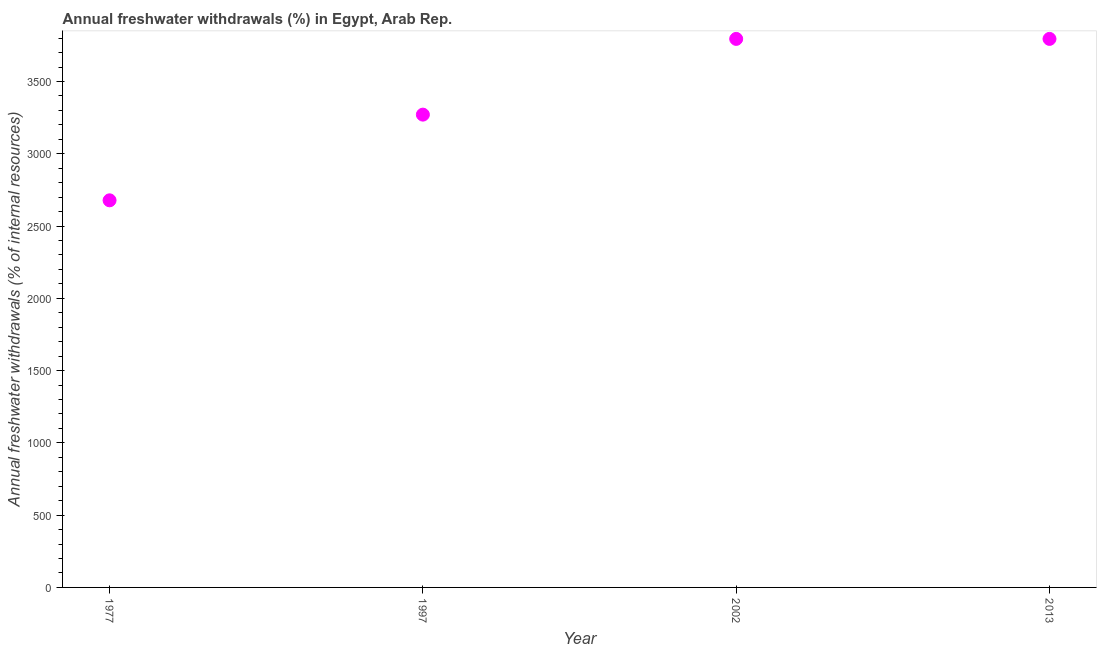What is the annual freshwater withdrawals in 1997?
Keep it short and to the point. 3270.56. Across all years, what is the maximum annual freshwater withdrawals?
Offer a very short reply. 3794.44. Across all years, what is the minimum annual freshwater withdrawals?
Offer a terse response. 2677.78. In which year was the annual freshwater withdrawals maximum?
Offer a terse response. 2002. In which year was the annual freshwater withdrawals minimum?
Make the answer very short. 1977. What is the sum of the annual freshwater withdrawals?
Your response must be concise. 1.35e+04. What is the difference between the annual freshwater withdrawals in 2002 and 2013?
Offer a terse response. 0. What is the average annual freshwater withdrawals per year?
Offer a very short reply. 3384.31. What is the median annual freshwater withdrawals?
Give a very brief answer. 3532.5. What is the ratio of the annual freshwater withdrawals in 1977 to that in 1997?
Ensure brevity in your answer.  0.82. Is the difference between the annual freshwater withdrawals in 1997 and 2002 greater than the difference between any two years?
Offer a very short reply. No. What is the difference between the highest and the second highest annual freshwater withdrawals?
Your answer should be very brief. 0. What is the difference between the highest and the lowest annual freshwater withdrawals?
Your answer should be compact. 1116.67. In how many years, is the annual freshwater withdrawals greater than the average annual freshwater withdrawals taken over all years?
Your answer should be very brief. 2. How many years are there in the graph?
Your response must be concise. 4. Does the graph contain grids?
Your answer should be compact. No. What is the title of the graph?
Make the answer very short. Annual freshwater withdrawals (%) in Egypt, Arab Rep. What is the label or title of the Y-axis?
Provide a short and direct response. Annual freshwater withdrawals (% of internal resources). What is the Annual freshwater withdrawals (% of internal resources) in 1977?
Provide a short and direct response. 2677.78. What is the Annual freshwater withdrawals (% of internal resources) in 1997?
Offer a very short reply. 3270.56. What is the Annual freshwater withdrawals (% of internal resources) in 2002?
Your answer should be very brief. 3794.44. What is the Annual freshwater withdrawals (% of internal resources) in 2013?
Give a very brief answer. 3794.44. What is the difference between the Annual freshwater withdrawals (% of internal resources) in 1977 and 1997?
Offer a very short reply. -592.78. What is the difference between the Annual freshwater withdrawals (% of internal resources) in 1977 and 2002?
Give a very brief answer. -1116.67. What is the difference between the Annual freshwater withdrawals (% of internal resources) in 1977 and 2013?
Provide a succinct answer. -1116.67. What is the difference between the Annual freshwater withdrawals (% of internal resources) in 1997 and 2002?
Provide a short and direct response. -523.89. What is the difference between the Annual freshwater withdrawals (% of internal resources) in 1997 and 2013?
Ensure brevity in your answer.  -523.89. What is the ratio of the Annual freshwater withdrawals (% of internal resources) in 1977 to that in 1997?
Ensure brevity in your answer.  0.82. What is the ratio of the Annual freshwater withdrawals (% of internal resources) in 1977 to that in 2002?
Give a very brief answer. 0.71. What is the ratio of the Annual freshwater withdrawals (% of internal resources) in 1977 to that in 2013?
Your response must be concise. 0.71. What is the ratio of the Annual freshwater withdrawals (% of internal resources) in 1997 to that in 2002?
Your response must be concise. 0.86. What is the ratio of the Annual freshwater withdrawals (% of internal resources) in 1997 to that in 2013?
Offer a very short reply. 0.86. 